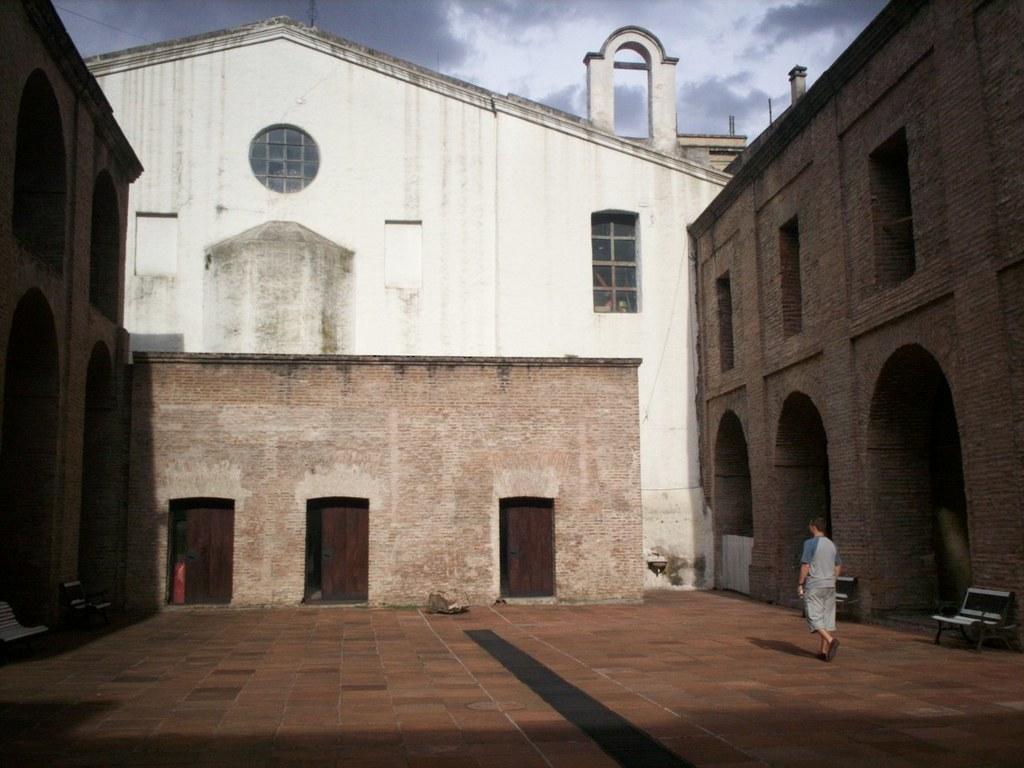Could you give a brief overview of what you see in this image? In this picture there is a man who is wearing t-shirt, short and the shoes. He is walking near to the bench. In the background I can see the buildings. At the bottom I can see the doors. At the top I can see the sky and clouds. 